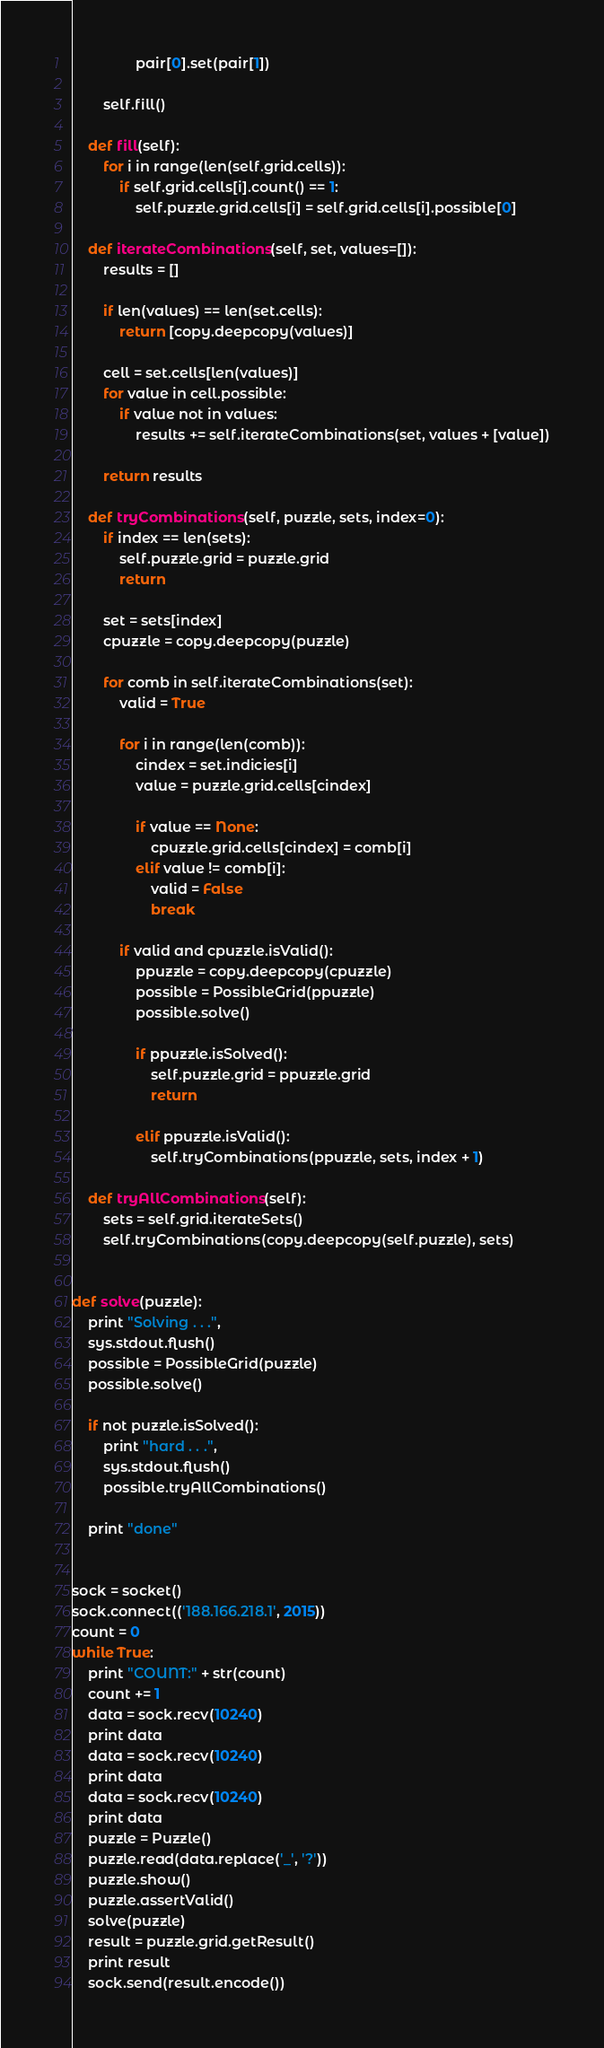Convert code to text. <code><loc_0><loc_0><loc_500><loc_500><_Python_>                pair[0].set(pair[1])

        self.fill()

    def fill(self):
        for i in range(len(self.grid.cells)):
            if self.grid.cells[i].count() == 1:
                self.puzzle.grid.cells[i] = self.grid.cells[i].possible[0]

    def iterateCombinations(self, set, values=[]):
        results = []

        if len(values) == len(set.cells):
            return [copy.deepcopy(values)]

        cell = set.cells[len(values)]
        for value in cell.possible:
            if value not in values:
                results += self.iterateCombinations(set, values + [value])

        return results

    def tryCombinations(self, puzzle, sets, index=0):
        if index == len(sets):
            self.puzzle.grid = puzzle.grid
            return

        set = sets[index]
        cpuzzle = copy.deepcopy(puzzle)

        for comb in self.iterateCombinations(set):
            valid = True

            for i in range(len(comb)):
                cindex = set.indicies[i]
                value = puzzle.grid.cells[cindex]

                if value == None:
                    cpuzzle.grid.cells[cindex] = comb[i]
                elif value != comb[i]:
                    valid = False
                    break

            if valid and cpuzzle.isValid():
                ppuzzle = copy.deepcopy(cpuzzle)
                possible = PossibleGrid(ppuzzle)
                possible.solve()

                if ppuzzle.isSolved():
                    self.puzzle.grid = ppuzzle.grid
                    return

                elif ppuzzle.isValid():
                    self.tryCombinations(ppuzzle, sets, index + 1)

    def tryAllCombinations(self):
        sets = self.grid.iterateSets()
        self.tryCombinations(copy.deepcopy(self.puzzle), sets)


def solve(puzzle):
    print "Solving . . .",
    sys.stdout.flush()
    possible = PossibleGrid(puzzle)
    possible.solve()

    if not puzzle.isSolved():
        print "hard . . .",
        sys.stdout.flush()
        possible.tryAllCombinations()

    print "done"


sock = socket()
sock.connect(('188.166.218.1', 2015))
count = 0
while True:
    print "COUNT:" + str(count)
    count += 1
    data = sock.recv(10240)
    print data
    data = sock.recv(10240)
    print data
    data = sock.recv(10240)
    print data
    puzzle = Puzzle()
    puzzle.read(data.replace('_', '?'))
    puzzle.show()
    puzzle.assertValid()
    solve(puzzle)
    result = puzzle.grid.getResult()
    print result
    sock.send(result.encode())

</code> 